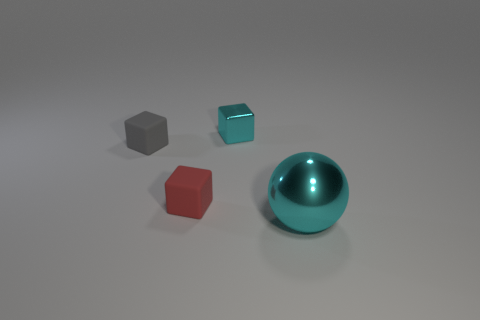What number of tiny cyan things are made of the same material as the gray cube?
Your answer should be compact. 0. What is the color of the metallic object on the right side of the cyan shiny thing that is on the left side of the metal sphere?
Keep it short and to the point. Cyan. What number of things are small rubber blocks or cyan objects that are behind the metal ball?
Offer a terse response. 3. Are there any metallic blocks of the same color as the big metallic object?
Your answer should be very brief. Yes. What number of red objects are balls or tiny blocks?
Provide a succinct answer. 1. How many other objects are there of the same size as the cyan shiny sphere?
Your answer should be compact. 0. How many large things are either gray matte cubes or cyan things?
Make the answer very short. 1. Does the gray rubber cube have the same size as the cyan thing to the left of the large cyan metallic object?
Your answer should be very brief. Yes. How many other things are the same shape as the gray thing?
Give a very brief answer. 2. The small object that is made of the same material as the gray block is what shape?
Provide a succinct answer. Cube. 